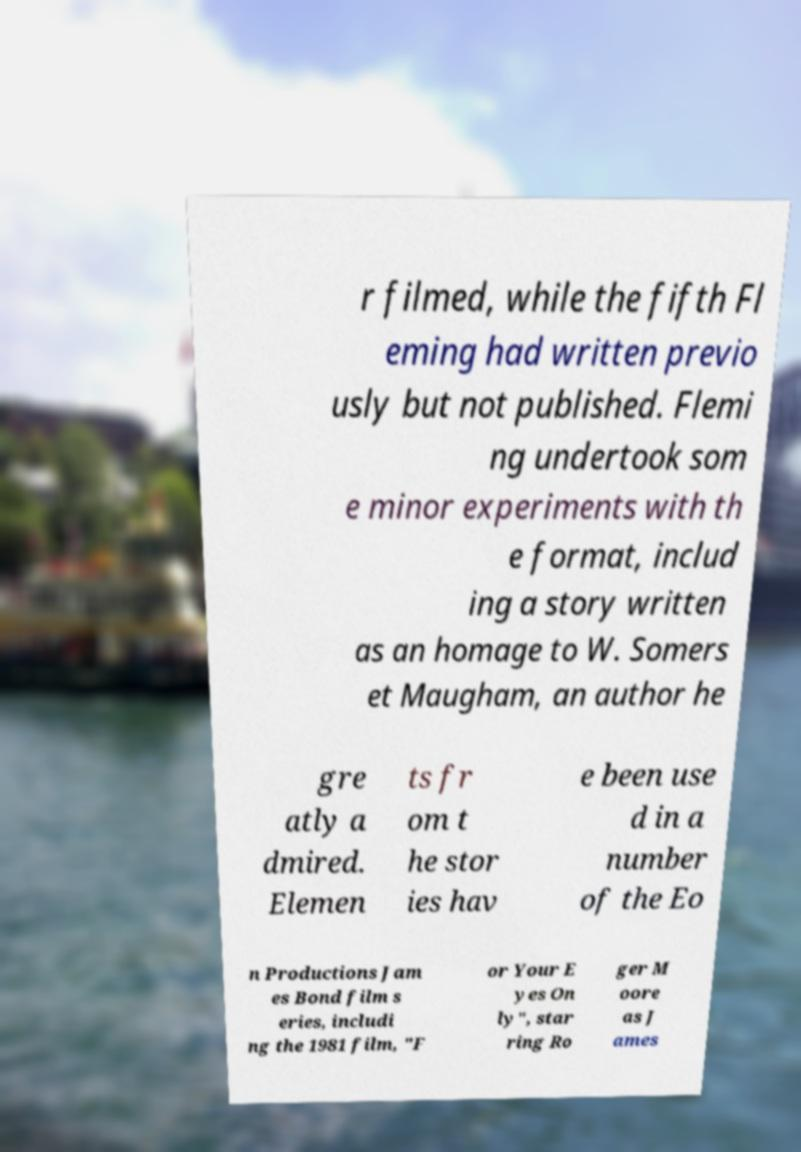I need the written content from this picture converted into text. Can you do that? r filmed, while the fifth Fl eming had written previo usly but not published. Flemi ng undertook som e minor experiments with th e format, includ ing a story written as an homage to W. Somers et Maugham, an author he gre atly a dmired. Elemen ts fr om t he stor ies hav e been use d in a number of the Eo n Productions Jam es Bond film s eries, includi ng the 1981 film, "F or Your E yes On ly", star ring Ro ger M oore as J ames 